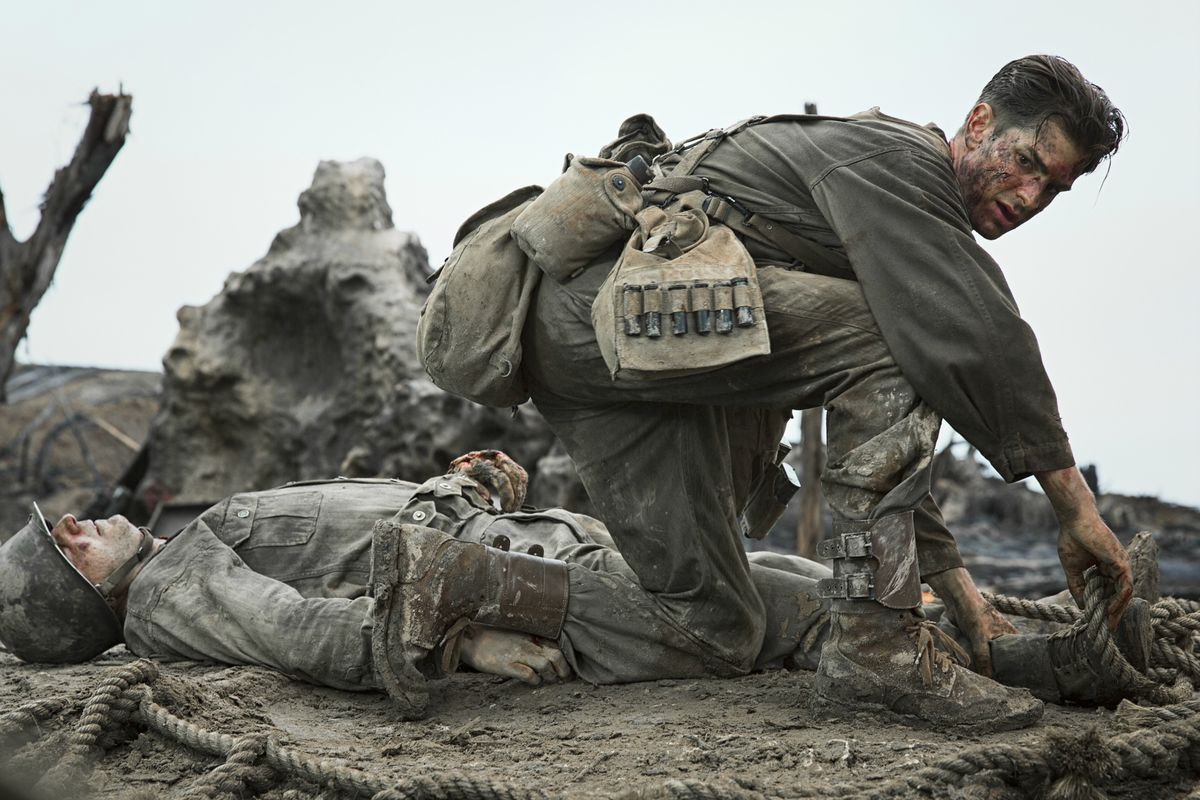Describe the following image. In this striking image from the film Hacksaw Ridge, we see actor Andrew Garfield in his role as Desmond Doss, a World War II medic. He is on a bleak, battle-scarred landscape, wearing a weathered and dirtied military uniform. Garfield's character, with a large medical supply backpack slung over his shoulders, is tenderly attending to two injured soldiers lying on the ground. His expression is a mix of determination and empathy, perfectly mirroring the agonizing tension of the scene. The backdrop is desolate, with dead trees and scattered debris emphasizing the devastation of war. This powerful visual underscores the harsh realities of battle and the compassionate bravery of those who serve. 